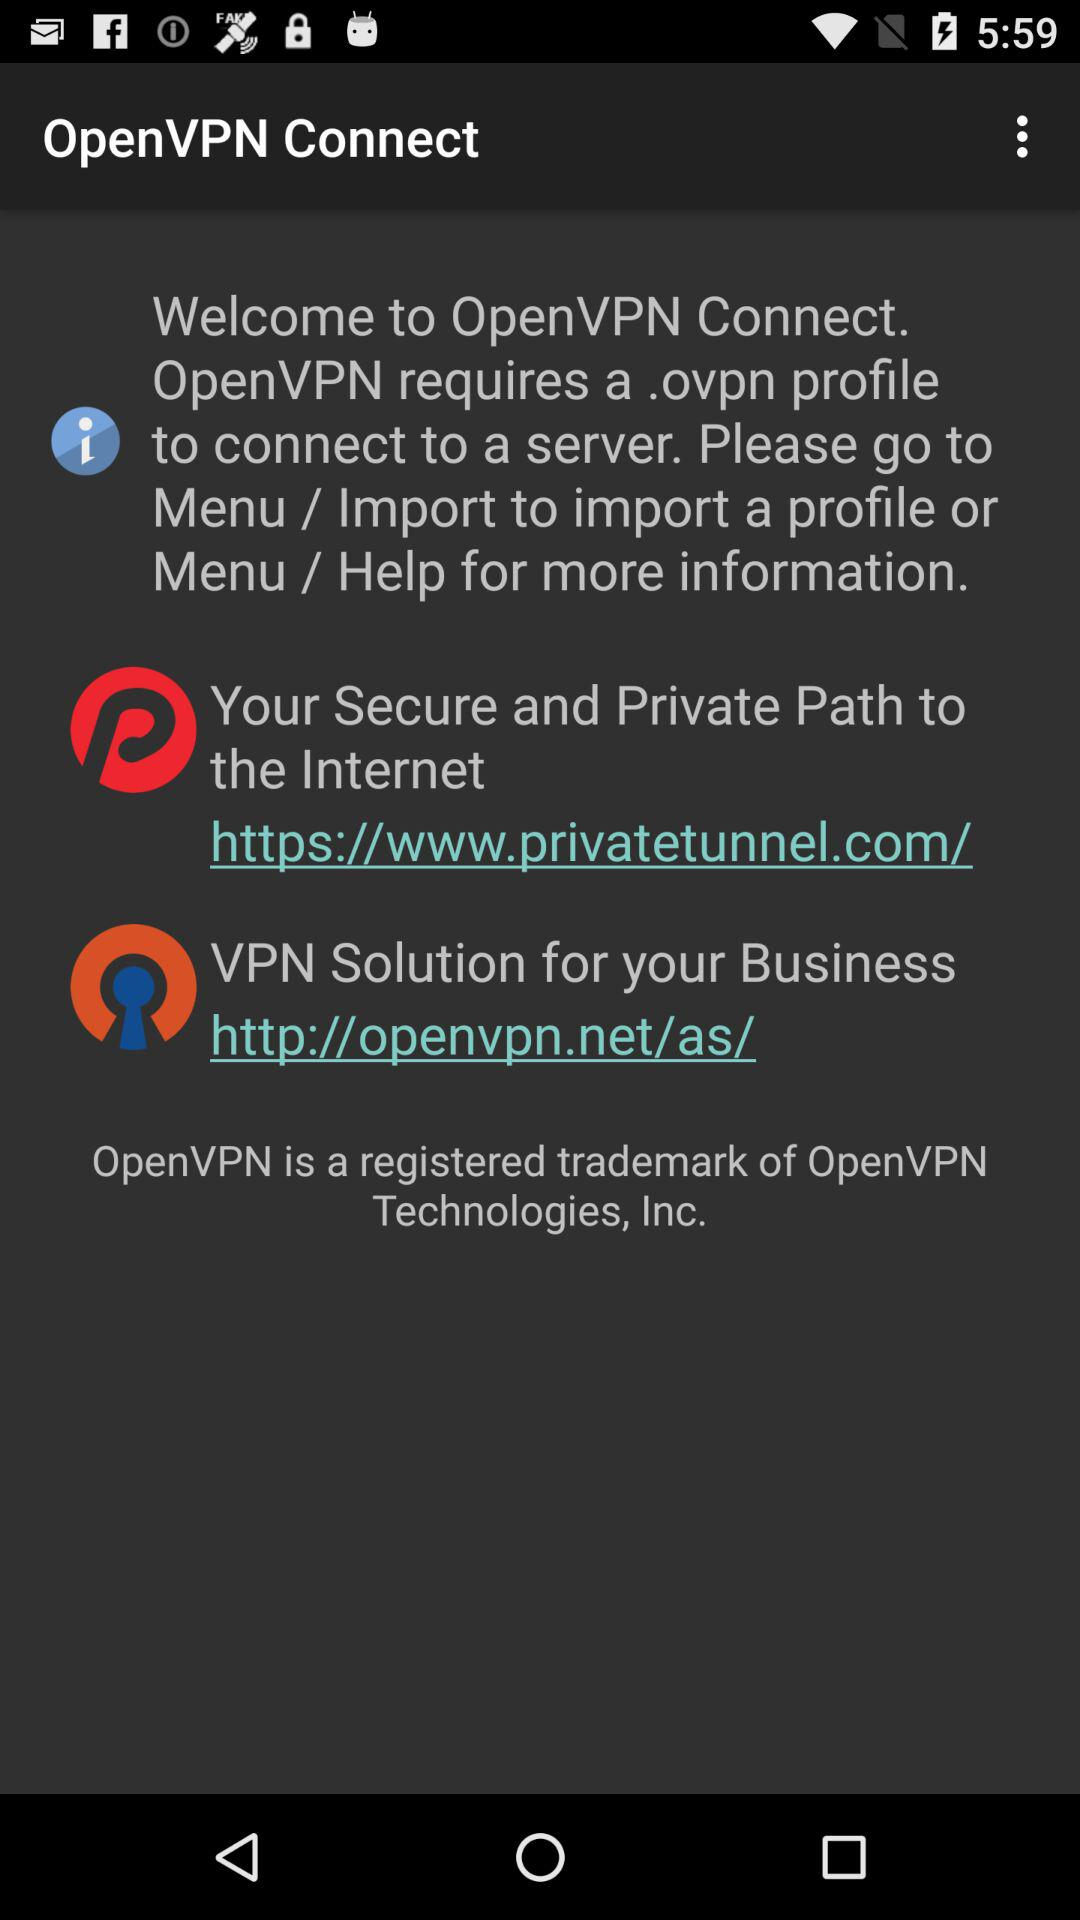What is the name of the application? The application name is "OpenVPN Connect". 